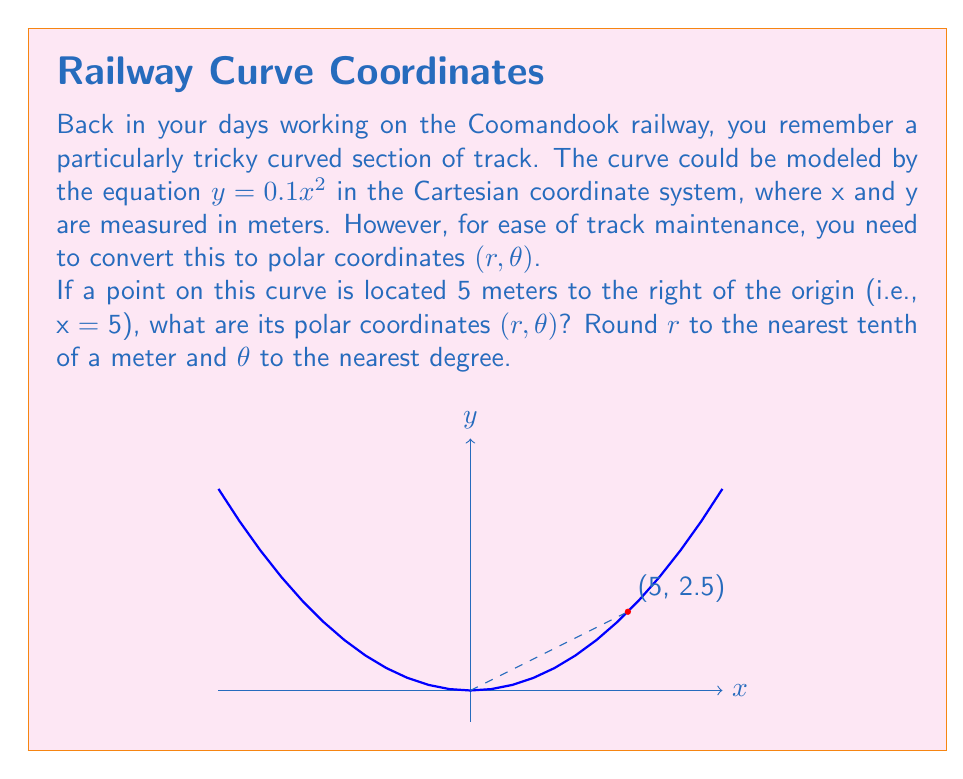What is the answer to this math problem? Let's approach this step-by-step:

1) We know that x = 5. To find y, we substitute this into the equation of the curve:
   $y = 0.1x^2 = 0.1(5)^2 = 0.1(25) = 2.5$

2) So, the point in Cartesian coordinates is (5, 2.5).

3) To convert to polar coordinates, we use these formulas:
   $r = \sqrt{x^2 + y^2}$
   $\theta = \tan^{-1}(\frac{y}{x})$

4) Let's calculate r:
   $r = \sqrt{5^2 + 2.5^2} = \sqrt{25 + 6.25} = \sqrt{31.25} \approx 5.59$ meters

5) Now for $\theta$:
   $\theta = \tan^{-1}(\frac{2.5}{5}) = \tan^{-1}(0.5)$

6) Using a calculator or trig table:
   $\tan^{-1}(0.5) \approx 26.57°$

7) Rounding to the nearest tenth for r and nearest degree for $\theta$:
   $r \approx 5.6$ meters
   $\theta \approx 27°$

Therefore, the polar coordinates are approximately (5.6, 27°).
Answer: $(5.6, 27°)$ 